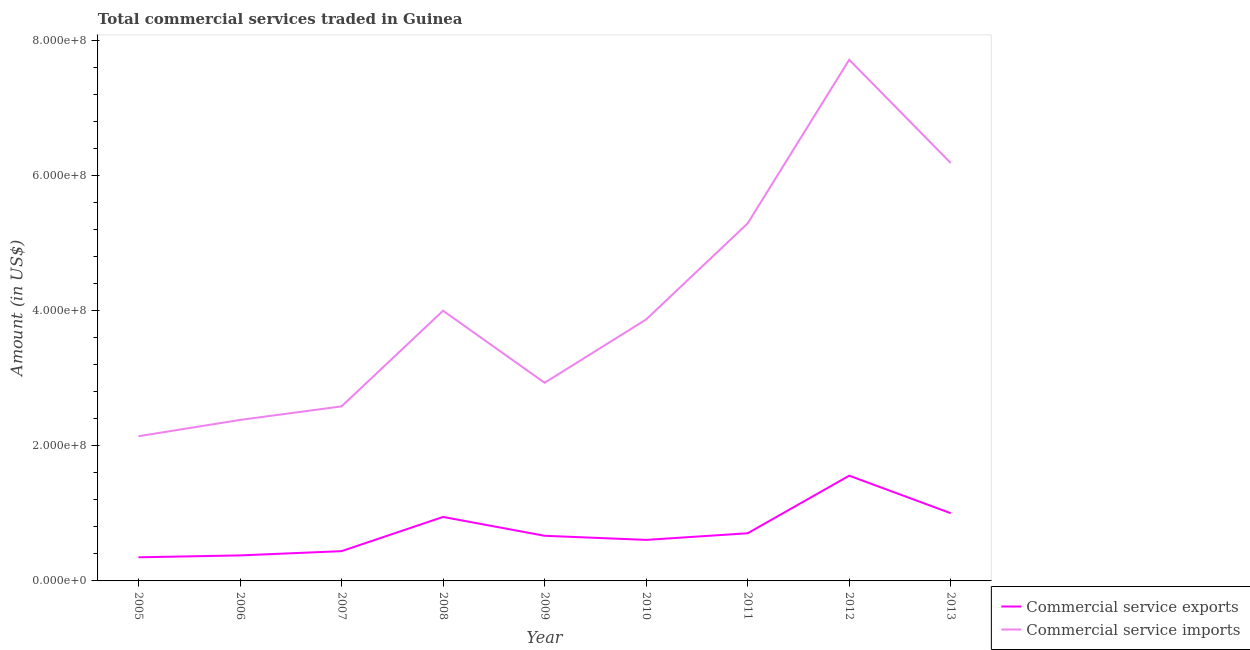How many different coloured lines are there?
Your response must be concise. 2. What is the amount of commercial service imports in 2012?
Offer a terse response. 7.72e+08. Across all years, what is the maximum amount of commercial service exports?
Provide a succinct answer. 1.56e+08. Across all years, what is the minimum amount of commercial service imports?
Keep it short and to the point. 2.14e+08. In which year was the amount of commercial service imports minimum?
Keep it short and to the point. 2005. What is the total amount of commercial service imports in the graph?
Your answer should be very brief. 3.71e+09. What is the difference between the amount of commercial service exports in 2005 and that in 2007?
Offer a very short reply. -9.09e+06. What is the difference between the amount of commercial service exports in 2007 and the amount of commercial service imports in 2005?
Provide a succinct answer. -1.70e+08. What is the average amount of commercial service imports per year?
Your answer should be compact. 4.13e+08. In the year 2012, what is the difference between the amount of commercial service imports and amount of commercial service exports?
Provide a short and direct response. 6.16e+08. In how many years, is the amount of commercial service exports greater than 720000000 US$?
Make the answer very short. 0. What is the ratio of the amount of commercial service exports in 2010 to that in 2013?
Your answer should be very brief. 0.61. Is the amount of commercial service exports in 2007 less than that in 2012?
Keep it short and to the point. Yes. What is the difference between the highest and the second highest amount of commercial service exports?
Give a very brief answer. 5.56e+07. What is the difference between the highest and the lowest amount of commercial service imports?
Provide a succinct answer. 5.58e+08. Is the sum of the amount of commercial service imports in 2010 and 2013 greater than the maximum amount of commercial service exports across all years?
Offer a very short reply. Yes. Does the amount of commercial service exports monotonically increase over the years?
Ensure brevity in your answer.  No. How many years are there in the graph?
Offer a terse response. 9. Does the graph contain any zero values?
Offer a very short reply. No. Does the graph contain grids?
Provide a succinct answer. No. How many legend labels are there?
Offer a terse response. 2. How are the legend labels stacked?
Offer a terse response. Vertical. What is the title of the graph?
Ensure brevity in your answer.  Total commercial services traded in Guinea. Does "IMF concessional" appear as one of the legend labels in the graph?
Your response must be concise. No. What is the label or title of the Y-axis?
Provide a short and direct response. Amount (in US$). What is the Amount (in US$) of Commercial service exports in 2005?
Your answer should be compact. 3.50e+07. What is the Amount (in US$) in Commercial service imports in 2005?
Ensure brevity in your answer.  2.14e+08. What is the Amount (in US$) in Commercial service exports in 2006?
Your response must be concise. 3.78e+07. What is the Amount (in US$) in Commercial service imports in 2006?
Your answer should be very brief. 2.38e+08. What is the Amount (in US$) in Commercial service exports in 2007?
Make the answer very short. 4.41e+07. What is the Amount (in US$) in Commercial service imports in 2007?
Make the answer very short. 2.59e+08. What is the Amount (in US$) in Commercial service exports in 2008?
Your answer should be very brief. 9.48e+07. What is the Amount (in US$) of Commercial service imports in 2008?
Your response must be concise. 4.00e+08. What is the Amount (in US$) in Commercial service exports in 2009?
Your answer should be compact. 6.69e+07. What is the Amount (in US$) in Commercial service imports in 2009?
Offer a terse response. 2.94e+08. What is the Amount (in US$) of Commercial service exports in 2010?
Your response must be concise. 6.08e+07. What is the Amount (in US$) of Commercial service imports in 2010?
Keep it short and to the point. 3.87e+08. What is the Amount (in US$) in Commercial service exports in 2011?
Ensure brevity in your answer.  7.06e+07. What is the Amount (in US$) of Commercial service imports in 2011?
Provide a succinct answer. 5.30e+08. What is the Amount (in US$) in Commercial service exports in 2012?
Your response must be concise. 1.56e+08. What is the Amount (in US$) in Commercial service imports in 2012?
Keep it short and to the point. 7.72e+08. What is the Amount (in US$) of Commercial service exports in 2013?
Provide a succinct answer. 1.00e+08. What is the Amount (in US$) of Commercial service imports in 2013?
Make the answer very short. 6.19e+08. Across all years, what is the maximum Amount (in US$) in Commercial service exports?
Offer a terse response. 1.56e+08. Across all years, what is the maximum Amount (in US$) in Commercial service imports?
Offer a very short reply. 7.72e+08. Across all years, what is the minimum Amount (in US$) in Commercial service exports?
Your answer should be compact. 3.50e+07. Across all years, what is the minimum Amount (in US$) in Commercial service imports?
Provide a short and direct response. 2.14e+08. What is the total Amount (in US$) in Commercial service exports in the graph?
Provide a succinct answer. 6.66e+08. What is the total Amount (in US$) of Commercial service imports in the graph?
Your answer should be compact. 3.71e+09. What is the difference between the Amount (in US$) in Commercial service exports in 2005 and that in 2006?
Offer a terse response. -2.79e+06. What is the difference between the Amount (in US$) in Commercial service imports in 2005 and that in 2006?
Offer a very short reply. -2.41e+07. What is the difference between the Amount (in US$) of Commercial service exports in 2005 and that in 2007?
Provide a succinct answer. -9.09e+06. What is the difference between the Amount (in US$) in Commercial service imports in 2005 and that in 2007?
Offer a terse response. -4.42e+07. What is the difference between the Amount (in US$) of Commercial service exports in 2005 and that in 2008?
Keep it short and to the point. -5.98e+07. What is the difference between the Amount (in US$) in Commercial service imports in 2005 and that in 2008?
Make the answer very short. -1.86e+08. What is the difference between the Amount (in US$) in Commercial service exports in 2005 and that in 2009?
Your answer should be compact. -3.19e+07. What is the difference between the Amount (in US$) of Commercial service imports in 2005 and that in 2009?
Offer a very short reply. -7.92e+07. What is the difference between the Amount (in US$) of Commercial service exports in 2005 and that in 2010?
Your response must be concise. -2.58e+07. What is the difference between the Amount (in US$) of Commercial service imports in 2005 and that in 2010?
Offer a very short reply. -1.73e+08. What is the difference between the Amount (in US$) of Commercial service exports in 2005 and that in 2011?
Your answer should be compact. -3.56e+07. What is the difference between the Amount (in US$) in Commercial service imports in 2005 and that in 2011?
Give a very brief answer. -3.15e+08. What is the difference between the Amount (in US$) in Commercial service exports in 2005 and that in 2012?
Keep it short and to the point. -1.21e+08. What is the difference between the Amount (in US$) of Commercial service imports in 2005 and that in 2012?
Provide a short and direct response. -5.58e+08. What is the difference between the Amount (in US$) of Commercial service exports in 2005 and that in 2013?
Your answer should be very brief. -6.53e+07. What is the difference between the Amount (in US$) of Commercial service imports in 2005 and that in 2013?
Keep it short and to the point. -4.05e+08. What is the difference between the Amount (in US$) of Commercial service exports in 2006 and that in 2007?
Give a very brief answer. -6.30e+06. What is the difference between the Amount (in US$) in Commercial service imports in 2006 and that in 2007?
Keep it short and to the point. -2.01e+07. What is the difference between the Amount (in US$) of Commercial service exports in 2006 and that in 2008?
Your response must be concise. -5.70e+07. What is the difference between the Amount (in US$) of Commercial service imports in 2006 and that in 2008?
Offer a very short reply. -1.62e+08. What is the difference between the Amount (in US$) in Commercial service exports in 2006 and that in 2009?
Provide a succinct answer. -2.91e+07. What is the difference between the Amount (in US$) of Commercial service imports in 2006 and that in 2009?
Provide a succinct answer. -5.50e+07. What is the difference between the Amount (in US$) of Commercial service exports in 2006 and that in 2010?
Your answer should be very brief. -2.30e+07. What is the difference between the Amount (in US$) in Commercial service imports in 2006 and that in 2010?
Provide a short and direct response. -1.49e+08. What is the difference between the Amount (in US$) in Commercial service exports in 2006 and that in 2011?
Offer a terse response. -3.28e+07. What is the difference between the Amount (in US$) of Commercial service imports in 2006 and that in 2011?
Your answer should be compact. -2.91e+08. What is the difference between the Amount (in US$) of Commercial service exports in 2006 and that in 2012?
Provide a short and direct response. -1.18e+08. What is the difference between the Amount (in US$) in Commercial service imports in 2006 and that in 2012?
Offer a very short reply. -5.34e+08. What is the difference between the Amount (in US$) in Commercial service exports in 2006 and that in 2013?
Ensure brevity in your answer.  -6.25e+07. What is the difference between the Amount (in US$) of Commercial service imports in 2006 and that in 2013?
Offer a terse response. -3.81e+08. What is the difference between the Amount (in US$) of Commercial service exports in 2007 and that in 2008?
Provide a short and direct response. -5.07e+07. What is the difference between the Amount (in US$) in Commercial service imports in 2007 and that in 2008?
Your answer should be compact. -1.42e+08. What is the difference between the Amount (in US$) of Commercial service exports in 2007 and that in 2009?
Offer a terse response. -2.28e+07. What is the difference between the Amount (in US$) in Commercial service imports in 2007 and that in 2009?
Give a very brief answer. -3.50e+07. What is the difference between the Amount (in US$) of Commercial service exports in 2007 and that in 2010?
Make the answer very short. -1.67e+07. What is the difference between the Amount (in US$) in Commercial service imports in 2007 and that in 2010?
Your answer should be very brief. -1.29e+08. What is the difference between the Amount (in US$) of Commercial service exports in 2007 and that in 2011?
Your answer should be compact. -2.65e+07. What is the difference between the Amount (in US$) of Commercial service imports in 2007 and that in 2011?
Keep it short and to the point. -2.71e+08. What is the difference between the Amount (in US$) in Commercial service exports in 2007 and that in 2012?
Your answer should be very brief. -1.12e+08. What is the difference between the Amount (in US$) in Commercial service imports in 2007 and that in 2012?
Offer a very short reply. -5.13e+08. What is the difference between the Amount (in US$) in Commercial service exports in 2007 and that in 2013?
Provide a short and direct response. -5.62e+07. What is the difference between the Amount (in US$) in Commercial service imports in 2007 and that in 2013?
Give a very brief answer. -3.60e+08. What is the difference between the Amount (in US$) of Commercial service exports in 2008 and that in 2009?
Your response must be concise. 2.79e+07. What is the difference between the Amount (in US$) in Commercial service imports in 2008 and that in 2009?
Provide a succinct answer. 1.07e+08. What is the difference between the Amount (in US$) of Commercial service exports in 2008 and that in 2010?
Your answer should be very brief. 3.40e+07. What is the difference between the Amount (in US$) of Commercial service imports in 2008 and that in 2010?
Offer a very short reply. 1.30e+07. What is the difference between the Amount (in US$) in Commercial service exports in 2008 and that in 2011?
Your answer should be very brief. 2.42e+07. What is the difference between the Amount (in US$) of Commercial service imports in 2008 and that in 2011?
Give a very brief answer. -1.29e+08. What is the difference between the Amount (in US$) in Commercial service exports in 2008 and that in 2012?
Make the answer very short. -6.11e+07. What is the difference between the Amount (in US$) in Commercial service imports in 2008 and that in 2012?
Provide a succinct answer. -3.72e+08. What is the difference between the Amount (in US$) in Commercial service exports in 2008 and that in 2013?
Offer a terse response. -5.55e+06. What is the difference between the Amount (in US$) in Commercial service imports in 2008 and that in 2013?
Offer a very short reply. -2.19e+08. What is the difference between the Amount (in US$) of Commercial service exports in 2009 and that in 2010?
Offer a very short reply. 6.08e+06. What is the difference between the Amount (in US$) in Commercial service imports in 2009 and that in 2010?
Your answer should be compact. -9.38e+07. What is the difference between the Amount (in US$) of Commercial service exports in 2009 and that in 2011?
Provide a short and direct response. -3.73e+06. What is the difference between the Amount (in US$) of Commercial service imports in 2009 and that in 2011?
Offer a very short reply. -2.36e+08. What is the difference between the Amount (in US$) of Commercial service exports in 2009 and that in 2012?
Ensure brevity in your answer.  -8.90e+07. What is the difference between the Amount (in US$) of Commercial service imports in 2009 and that in 2012?
Your answer should be compact. -4.79e+08. What is the difference between the Amount (in US$) in Commercial service exports in 2009 and that in 2013?
Provide a succinct answer. -3.35e+07. What is the difference between the Amount (in US$) in Commercial service imports in 2009 and that in 2013?
Give a very brief answer. -3.26e+08. What is the difference between the Amount (in US$) in Commercial service exports in 2010 and that in 2011?
Your response must be concise. -9.81e+06. What is the difference between the Amount (in US$) of Commercial service imports in 2010 and that in 2011?
Provide a succinct answer. -1.42e+08. What is the difference between the Amount (in US$) in Commercial service exports in 2010 and that in 2012?
Give a very brief answer. -9.51e+07. What is the difference between the Amount (in US$) of Commercial service imports in 2010 and that in 2012?
Your answer should be compact. -3.85e+08. What is the difference between the Amount (in US$) in Commercial service exports in 2010 and that in 2013?
Your response must be concise. -3.96e+07. What is the difference between the Amount (in US$) of Commercial service imports in 2010 and that in 2013?
Give a very brief answer. -2.32e+08. What is the difference between the Amount (in US$) in Commercial service exports in 2011 and that in 2012?
Your answer should be compact. -8.53e+07. What is the difference between the Amount (in US$) in Commercial service imports in 2011 and that in 2012?
Offer a very short reply. -2.42e+08. What is the difference between the Amount (in US$) of Commercial service exports in 2011 and that in 2013?
Make the answer very short. -2.97e+07. What is the difference between the Amount (in US$) in Commercial service imports in 2011 and that in 2013?
Your answer should be very brief. -8.94e+07. What is the difference between the Amount (in US$) of Commercial service exports in 2012 and that in 2013?
Your answer should be compact. 5.56e+07. What is the difference between the Amount (in US$) in Commercial service imports in 2012 and that in 2013?
Provide a short and direct response. 1.53e+08. What is the difference between the Amount (in US$) of Commercial service exports in 2005 and the Amount (in US$) of Commercial service imports in 2006?
Make the answer very short. -2.03e+08. What is the difference between the Amount (in US$) in Commercial service exports in 2005 and the Amount (in US$) in Commercial service imports in 2007?
Give a very brief answer. -2.24e+08. What is the difference between the Amount (in US$) of Commercial service exports in 2005 and the Amount (in US$) of Commercial service imports in 2008?
Offer a very short reply. -3.65e+08. What is the difference between the Amount (in US$) in Commercial service exports in 2005 and the Amount (in US$) in Commercial service imports in 2009?
Make the answer very short. -2.59e+08. What is the difference between the Amount (in US$) of Commercial service exports in 2005 and the Amount (in US$) of Commercial service imports in 2010?
Offer a very short reply. -3.52e+08. What is the difference between the Amount (in US$) in Commercial service exports in 2005 and the Amount (in US$) in Commercial service imports in 2011?
Offer a terse response. -4.95e+08. What is the difference between the Amount (in US$) of Commercial service exports in 2005 and the Amount (in US$) of Commercial service imports in 2012?
Your answer should be very brief. -7.37e+08. What is the difference between the Amount (in US$) in Commercial service exports in 2005 and the Amount (in US$) in Commercial service imports in 2013?
Provide a succinct answer. -5.84e+08. What is the difference between the Amount (in US$) in Commercial service exports in 2006 and the Amount (in US$) in Commercial service imports in 2007?
Offer a terse response. -2.21e+08. What is the difference between the Amount (in US$) in Commercial service exports in 2006 and the Amount (in US$) in Commercial service imports in 2008?
Offer a terse response. -3.62e+08. What is the difference between the Amount (in US$) in Commercial service exports in 2006 and the Amount (in US$) in Commercial service imports in 2009?
Make the answer very short. -2.56e+08. What is the difference between the Amount (in US$) in Commercial service exports in 2006 and the Amount (in US$) in Commercial service imports in 2010?
Your answer should be very brief. -3.50e+08. What is the difference between the Amount (in US$) of Commercial service exports in 2006 and the Amount (in US$) of Commercial service imports in 2011?
Your response must be concise. -4.92e+08. What is the difference between the Amount (in US$) of Commercial service exports in 2006 and the Amount (in US$) of Commercial service imports in 2012?
Offer a very short reply. -7.34e+08. What is the difference between the Amount (in US$) of Commercial service exports in 2006 and the Amount (in US$) of Commercial service imports in 2013?
Offer a very short reply. -5.81e+08. What is the difference between the Amount (in US$) in Commercial service exports in 2007 and the Amount (in US$) in Commercial service imports in 2008?
Make the answer very short. -3.56e+08. What is the difference between the Amount (in US$) of Commercial service exports in 2007 and the Amount (in US$) of Commercial service imports in 2009?
Make the answer very short. -2.49e+08. What is the difference between the Amount (in US$) in Commercial service exports in 2007 and the Amount (in US$) in Commercial service imports in 2010?
Your answer should be compact. -3.43e+08. What is the difference between the Amount (in US$) in Commercial service exports in 2007 and the Amount (in US$) in Commercial service imports in 2011?
Keep it short and to the point. -4.86e+08. What is the difference between the Amount (in US$) of Commercial service exports in 2007 and the Amount (in US$) of Commercial service imports in 2012?
Keep it short and to the point. -7.28e+08. What is the difference between the Amount (in US$) in Commercial service exports in 2007 and the Amount (in US$) in Commercial service imports in 2013?
Give a very brief answer. -5.75e+08. What is the difference between the Amount (in US$) in Commercial service exports in 2008 and the Amount (in US$) in Commercial service imports in 2009?
Ensure brevity in your answer.  -1.99e+08. What is the difference between the Amount (in US$) of Commercial service exports in 2008 and the Amount (in US$) of Commercial service imports in 2010?
Your response must be concise. -2.93e+08. What is the difference between the Amount (in US$) of Commercial service exports in 2008 and the Amount (in US$) of Commercial service imports in 2011?
Your answer should be compact. -4.35e+08. What is the difference between the Amount (in US$) of Commercial service exports in 2008 and the Amount (in US$) of Commercial service imports in 2012?
Give a very brief answer. -6.77e+08. What is the difference between the Amount (in US$) of Commercial service exports in 2008 and the Amount (in US$) of Commercial service imports in 2013?
Offer a very short reply. -5.24e+08. What is the difference between the Amount (in US$) in Commercial service exports in 2009 and the Amount (in US$) in Commercial service imports in 2010?
Offer a terse response. -3.20e+08. What is the difference between the Amount (in US$) in Commercial service exports in 2009 and the Amount (in US$) in Commercial service imports in 2011?
Make the answer very short. -4.63e+08. What is the difference between the Amount (in US$) in Commercial service exports in 2009 and the Amount (in US$) in Commercial service imports in 2012?
Provide a short and direct response. -7.05e+08. What is the difference between the Amount (in US$) of Commercial service exports in 2009 and the Amount (in US$) of Commercial service imports in 2013?
Keep it short and to the point. -5.52e+08. What is the difference between the Amount (in US$) of Commercial service exports in 2010 and the Amount (in US$) of Commercial service imports in 2011?
Offer a very short reply. -4.69e+08. What is the difference between the Amount (in US$) in Commercial service exports in 2010 and the Amount (in US$) in Commercial service imports in 2012?
Provide a succinct answer. -7.11e+08. What is the difference between the Amount (in US$) in Commercial service exports in 2010 and the Amount (in US$) in Commercial service imports in 2013?
Make the answer very short. -5.58e+08. What is the difference between the Amount (in US$) in Commercial service exports in 2011 and the Amount (in US$) in Commercial service imports in 2012?
Provide a succinct answer. -7.01e+08. What is the difference between the Amount (in US$) of Commercial service exports in 2011 and the Amount (in US$) of Commercial service imports in 2013?
Make the answer very short. -5.48e+08. What is the difference between the Amount (in US$) of Commercial service exports in 2012 and the Amount (in US$) of Commercial service imports in 2013?
Keep it short and to the point. -4.63e+08. What is the average Amount (in US$) in Commercial service exports per year?
Provide a succinct answer. 7.40e+07. What is the average Amount (in US$) in Commercial service imports per year?
Provide a short and direct response. 4.13e+08. In the year 2005, what is the difference between the Amount (in US$) of Commercial service exports and Amount (in US$) of Commercial service imports?
Offer a terse response. -1.79e+08. In the year 2006, what is the difference between the Amount (in US$) of Commercial service exports and Amount (in US$) of Commercial service imports?
Keep it short and to the point. -2.01e+08. In the year 2007, what is the difference between the Amount (in US$) in Commercial service exports and Amount (in US$) in Commercial service imports?
Give a very brief answer. -2.14e+08. In the year 2008, what is the difference between the Amount (in US$) of Commercial service exports and Amount (in US$) of Commercial service imports?
Keep it short and to the point. -3.05e+08. In the year 2009, what is the difference between the Amount (in US$) in Commercial service exports and Amount (in US$) in Commercial service imports?
Your answer should be compact. -2.27e+08. In the year 2010, what is the difference between the Amount (in US$) of Commercial service exports and Amount (in US$) of Commercial service imports?
Give a very brief answer. -3.27e+08. In the year 2011, what is the difference between the Amount (in US$) of Commercial service exports and Amount (in US$) of Commercial service imports?
Provide a succinct answer. -4.59e+08. In the year 2012, what is the difference between the Amount (in US$) of Commercial service exports and Amount (in US$) of Commercial service imports?
Make the answer very short. -6.16e+08. In the year 2013, what is the difference between the Amount (in US$) of Commercial service exports and Amount (in US$) of Commercial service imports?
Offer a terse response. -5.19e+08. What is the ratio of the Amount (in US$) in Commercial service exports in 2005 to that in 2006?
Your answer should be compact. 0.93. What is the ratio of the Amount (in US$) of Commercial service imports in 2005 to that in 2006?
Offer a terse response. 0.9. What is the ratio of the Amount (in US$) of Commercial service exports in 2005 to that in 2007?
Offer a very short reply. 0.79. What is the ratio of the Amount (in US$) in Commercial service imports in 2005 to that in 2007?
Make the answer very short. 0.83. What is the ratio of the Amount (in US$) of Commercial service exports in 2005 to that in 2008?
Provide a succinct answer. 0.37. What is the ratio of the Amount (in US$) of Commercial service imports in 2005 to that in 2008?
Provide a short and direct response. 0.54. What is the ratio of the Amount (in US$) of Commercial service exports in 2005 to that in 2009?
Provide a succinct answer. 0.52. What is the ratio of the Amount (in US$) in Commercial service imports in 2005 to that in 2009?
Provide a short and direct response. 0.73. What is the ratio of the Amount (in US$) of Commercial service exports in 2005 to that in 2010?
Provide a short and direct response. 0.58. What is the ratio of the Amount (in US$) of Commercial service imports in 2005 to that in 2010?
Provide a succinct answer. 0.55. What is the ratio of the Amount (in US$) in Commercial service exports in 2005 to that in 2011?
Ensure brevity in your answer.  0.5. What is the ratio of the Amount (in US$) in Commercial service imports in 2005 to that in 2011?
Provide a succinct answer. 0.4. What is the ratio of the Amount (in US$) of Commercial service exports in 2005 to that in 2012?
Provide a short and direct response. 0.22. What is the ratio of the Amount (in US$) of Commercial service imports in 2005 to that in 2012?
Offer a terse response. 0.28. What is the ratio of the Amount (in US$) of Commercial service exports in 2005 to that in 2013?
Offer a terse response. 0.35. What is the ratio of the Amount (in US$) in Commercial service imports in 2005 to that in 2013?
Offer a very short reply. 0.35. What is the ratio of the Amount (in US$) in Commercial service imports in 2006 to that in 2007?
Give a very brief answer. 0.92. What is the ratio of the Amount (in US$) in Commercial service exports in 2006 to that in 2008?
Offer a terse response. 0.4. What is the ratio of the Amount (in US$) in Commercial service imports in 2006 to that in 2008?
Your answer should be very brief. 0.6. What is the ratio of the Amount (in US$) in Commercial service exports in 2006 to that in 2009?
Provide a short and direct response. 0.57. What is the ratio of the Amount (in US$) in Commercial service imports in 2006 to that in 2009?
Make the answer very short. 0.81. What is the ratio of the Amount (in US$) in Commercial service exports in 2006 to that in 2010?
Keep it short and to the point. 0.62. What is the ratio of the Amount (in US$) in Commercial service imports in 2006 to that in 2010?
Make the answer very short. 0.62. What is the ratio of the Amount (in US$) of Commercial service exports in 2006 to that in 2011?
Your response must be concise. 0.54. What is the ratio of the Amount (in US$) in Commercial service imports in 2006 to that in 2011?
Provide a short and direct response. 0.45. What is the ratio of the Amount (in US$) in Commercial service exports in 2006 to that in 2012?
Your answer should be compact. 0.24. What is the ratio of the Amount (in US$) in Commercial service imports in 2006 to that in 2012?
Provide a succinct answer. 0.31. What is the ratio of the Amount (in US$) in Commercial service exports in 2006 to that in 2013?
Keep it short and to the point. 0.38. What is the ratio of the Amount (in US$) of Commercial service imports in 2006 to that in 2013?
Offer a very short reply. 0.39. What is the ratio of the Amount (in US$) in Commercial service exports in 2007 to that in 2008?
Offer a very short reply. 0.47. What is the ratio of the Amount (in US$) in Commercial service imports in 2007 to that in 2008?
Give a very brief answer. 0.65. What is the ratio of the Amount (in US$) of Commercial service exports in 2007 to that in 2009?
Keep it short and to the point. 0.66. What is the ratio of the Amount (in US$) in Commercial service imports in 2007 to that in 2009?
Offer a very short reply. 0.88. What is the ratio of the Amount (in US$) of Commercial service exports in 2007 to that in 2010?
Give a very brief answer. 0.73. What is the ratio of the Amount (in US$) in Commercial service imports in 2007 to that in 2010?
Keep it short and to the point. 0.67. What is the ratio of the Amount (in US$) of Commercial service exports in 2007 to that in 2011?
Make the answer very short. 0.62. What is the ratio of the Amount (in US$) of Commercial service imports in 2007 to that in 2011?
Offer a very short reply. 0.49. What is the ratio of the Amount (in US$) in Commercial service exports in 2007 to that in 2012?
Offer a very short reply. 0.28. What is the ratio of the Amount (in US$) in Commercial service imports in 2007 to that in 2012?
Ensure brevity in your answer.  0.33. What is the ratio of the Amount (in US$) in Commercial service exports in 2007 to that in 2013?
Keep it short and to the point. 0.44. What is the ratio of the Amount (in US$) of Commercial service imports in 2007 to that in 2013?
Keep it short and to the point. 0.42. What is the ratio of the Amount (in US$) in Commercial service exports in 2008 to that in 2009?
Ensure brevity in your answer.  1.42. What is the ratio of the Amount (in US$) of Commercial service imports in 2008 to that in 2009?
Make the answer very short. 1.36. What is the ratio of the Amount (in US$) in Commercial service exports in 2008 to that in 2010?
Make the answer very short. 1.56. What is the ratio of the Amount (in US$) in Commercial service imports in 2008 to that in 2010?
Your answer should be compact. 1.03. What is the ratio of the Amount (in US$) of Commercial service exports in 2008 to that in 2011?
Your answer should be compact. 1.34. What is the ratio of the Amount (in US$) in Commercial service imports in 2008 to that in 2011?
Provide a short and direct response. 0.76. What is the ratio of the Amount (in US$) in Commercial service exports in 2008 to that in 2012?
Your answer should be compact. 0.61. What is the ratio of the Amount (in US$) of Commercial service imports in 2008 to that in 2012?
Offer a very short reply. 0.52. What is the ratio of the Amount (in US$) of Commercial service exports in 2008 to that in 2013?
Keep it short and to the point. 0.94. What is the ratio of the Amount (in US$) of Commercial service imports in 2008 to that in 2013?
Your response must be concise. 0.65. What is the ratio of the Amount (in US$) of Commercial service imports in 2009 to that in 2010?
Make the answer very short. 0.76. What is the ratio of the Amount (in US$) of Commercial service exports in 2009 to that in 2011?
Offer a very short reply. 0.95. What is the ratio of the Amount (in US$) in Commercial service imports in 2009 to that in 2011?
Offer a terse response. 0.55. What is the ratio of the Amount (in US$) of Commercial service exports in 2009 to that in 2012?
Your answer should be compact. 0.43. What is the ratio of the Amount (in US$) in Commercial service imports in 2009 to that in 2012?
Offer a very short reply. 0.38. What is the ratio of the Amount (in US$) in Commercial service exports in 2009 to that in 2013?
Your answer should be very brief. 0.67. What is the ratio of the Amount (in US$) of Commercial service imports in 2009 to that in 2013?
Make the answer very short. 0.47. What is the ratio of the Amount (in US$) of Commercial service exports in 2010 to that in 2011?
Offer a very short reply. 0.86. What is the ratio of the Amount (in US$) in Commercial service imports in 2010 to that in 2011?
Offer a terse response. 0.73. What is the ratio of the Amount (in US$) in Commercial service exports in 2010 to that in 2012?
Make the answer very short. 0.39. What is the ratio of the Amount (in US$) in Commercial service imports in 2010 to that in 2012?
Ensure brevity in your answer.  0.5. What is the ratio of the Amount (in US$) of Commercial service exports in 2010 to that in 2013?
Your answer should be very brief. 0.61. What is the ratio of the Amount (in US$) in Commercial service imports in 2010 to that in 2013?
Keep it short and to the point. 0.63. What is the ratio of the Amount (in US$) of Commercial service exports in 2011 to that in 2012?
Your answer should be very brief. 0.45. What is the ratio of the Amount (in US$) of Commercial service imports in 2011 to that in 2012?
Give a very brief answer. 0.69. What is the ratio of the Amount (in US$) in Commercial service exports in 2011 to that in 2013?
Your answer should be compact. 0.7. What is the ratio of the Amount (in US$) in Commercial service imports in 2011 to that in 2013?
Offer a terse response. 0.86. What is the ratio of the Amount (in US$) of Commercial service exports in 2012 to that in 2013?
Your answer should be compact. 1.55. What is the ratio of the Amount (in US$) of Commercial service imports in 2012 to that in 2013?
Your answer should be compact. 1.25. What is the difference between the highest and the second highest Amount (in US$) in Commercial service exports?
Provide a succinct answer. 5.56e+07. What is the difference between the highest and the second highest Amount (in US$) of Commercial service imports?
Your answer should be very brief. 1.53e+08. What is the difference between the highest and the lowest Amount (in US$) of Commercial service exports?
Give a very brief answer. 1.21e+08. What is the difference between the highest and the lowest Amount (in US$) of Commercial service imports?
Your response must be concise. 5.58e+08. 